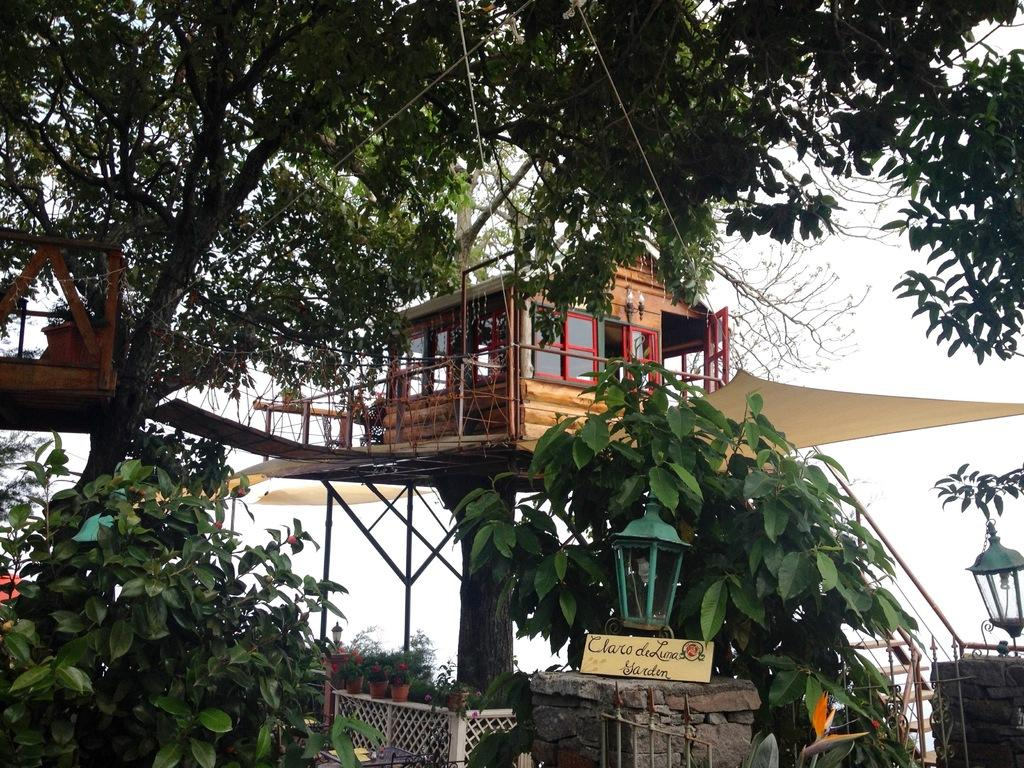What structure can be seen in the image? There is a tree house in the image. Where is the tree house located? The tree house is on a tree. What can be seen around the tree house? There are plants and trees around the tree house. What is visible above the tree house? The sky is visible above the tree house. What type of button is used to control the history of the tree house? There is no button or history of the tree house mentioned in the image. The image only shows a tree house on a tree with plants and trees around it, and the sky visible above it. 